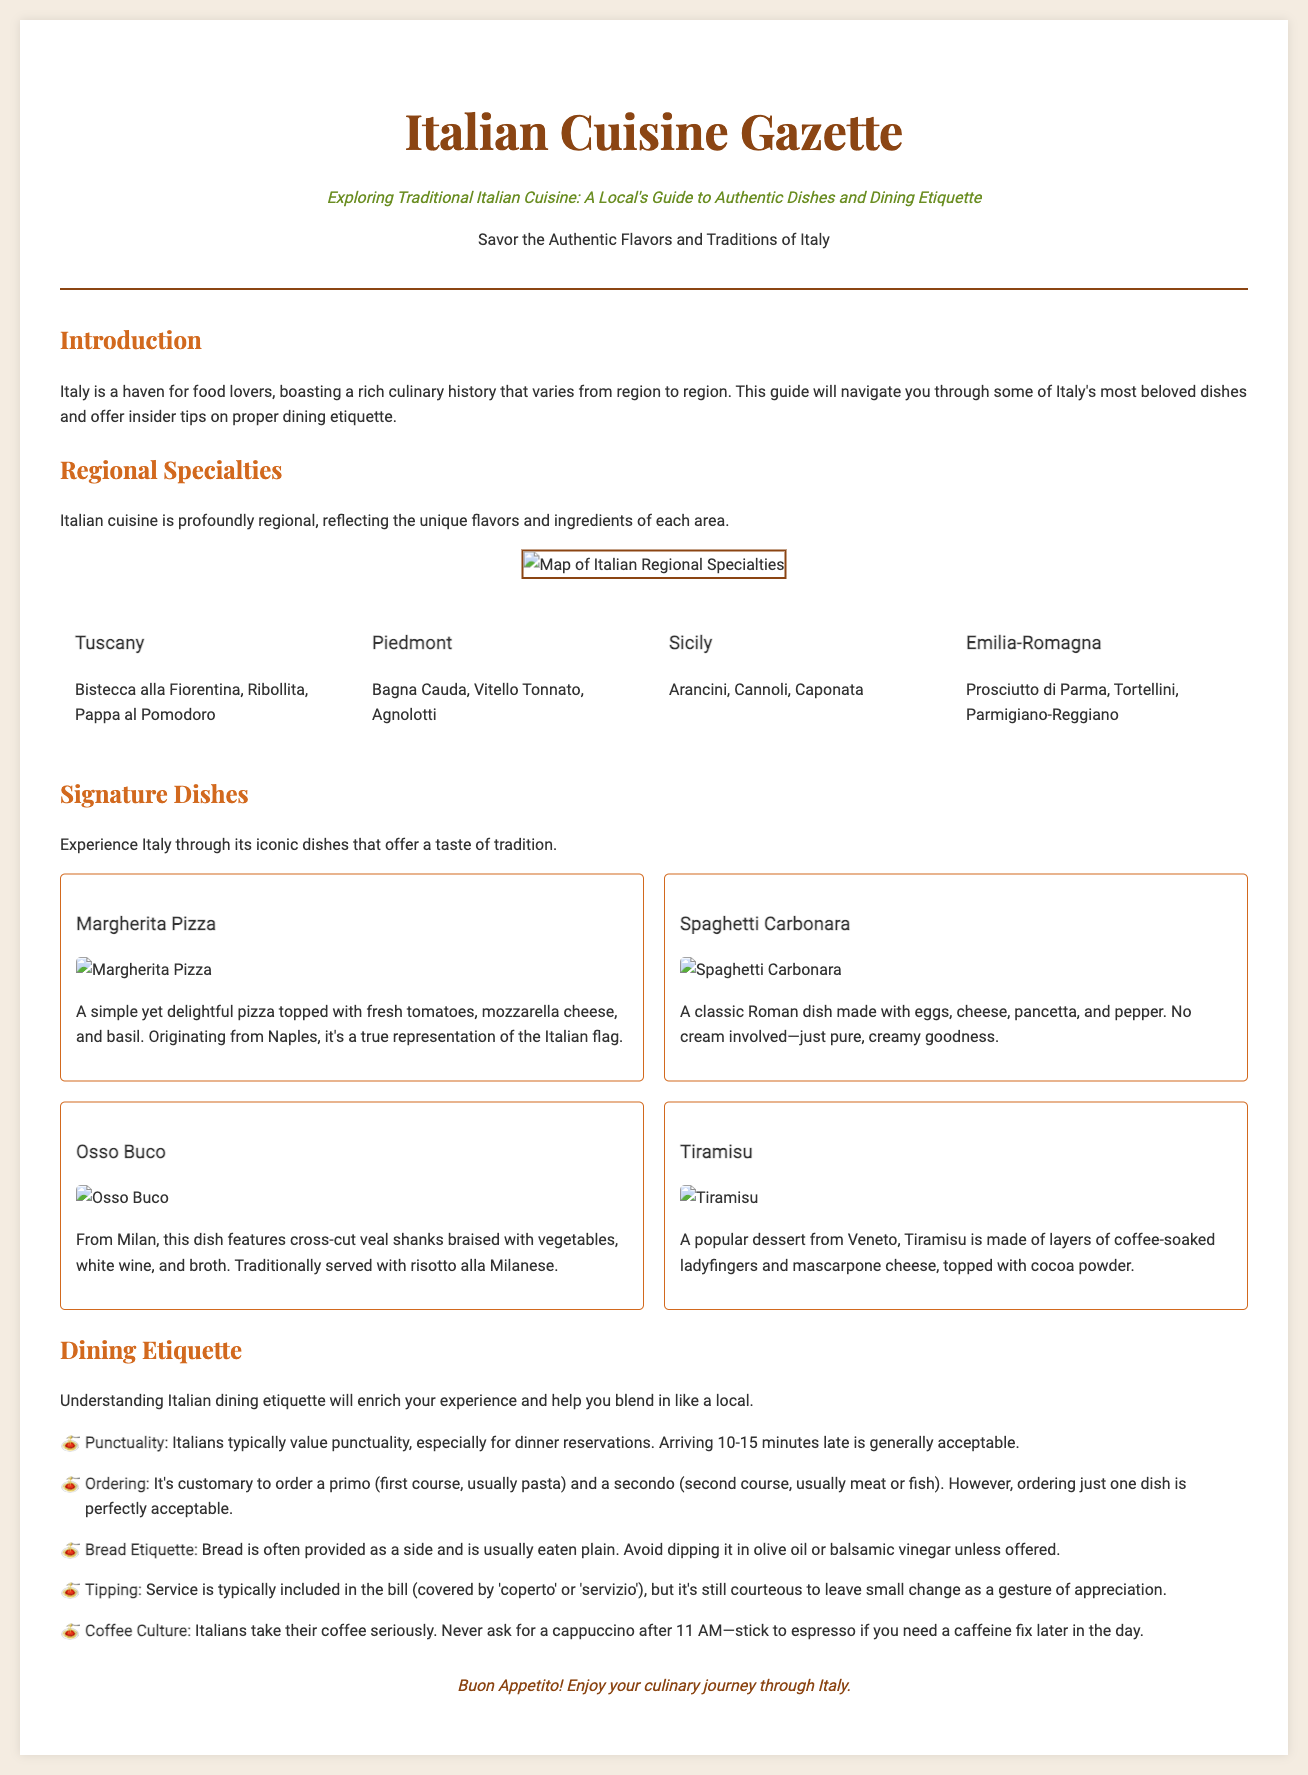What is the title of the newspaper? The title of the newspaper is stated prominently at the top of the document, reflecting the focus on Italian cuisine.
Answer: Italian Cuisine Gazette What dish is associated with Naples? The dish specifically mentioned as originating from Naples is highlighted in the signature dishes section.
Answer: Margherita Pizza Which region is known for Tiramisu? The region associated with Tiramisu, as noted in the signature dishes section, is listed alongside this iconic dessert.
Answer: Veneto What is the typical first course in an Italian meal? The document indicates the customary first course that is usually ordered in an Italian meal.
Answer: Primo What is considered courteous regarding tipping? The document emphasizes the cultural practice regarding tipping after discussing service charges in the bill.
Answer: Small change How many signature dishes are listed in the document? The total number of signature dishes provided in the signature dishes section is a specific count given.
Answer: Four What beverage should not be ordered after 11 AM in Italy? The specific beverage that Italians typically do not order after a certain time is noted in the dining etiquette section.
Answer: Cappuccino What type of image is included to illustrate regional specialties? The document describes the type of image that accompanies the regional specialties section to provide visual context.
Answer: Map What flavor does the Bistecca alla Fiorentina represent? Understanding the importance of a specific dish in Tuscan cuisine reveals insights into traditional flavor profiles.
Answer: Turkish 